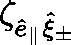<formula> <loc_0><loc_0><loc_500><loc_500>\zeta _ { \hat { e } _ { \| } \hat { \xi } _ { \pm } }</formula> 